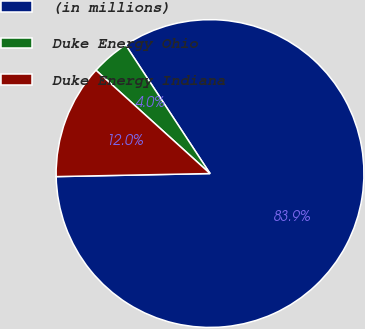Convert chart. <chart><loc_0><loc_0><loc_500><loc_500><pie_chart><fcel>(in millions)<fcel>Duke Energy Ohio<fcel>Duke Energy Indiana<nl><fcel>83.93%<fcel>4.04%<fcel>12.03%<nl></chart> 